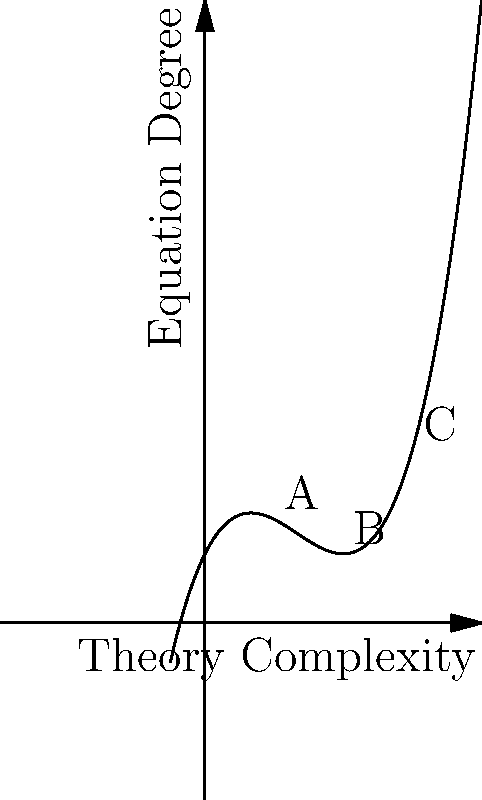In the context of scientific theory complexity and polynomial equation degree, the graph above represents a hypothetical relationship between these two variables. Points A, B, and C correspond to three distinct scientific theories. If we consider the rate of change in equation degree with respect to theory complexity, which theory demonstrates the most rapid increase in equation degree as complexity grows? To determine which theory demonstrates the most rapid increase in equation degree as complexity grows, we need to analyze the rate of change (slope) at each point:

1. The graph represents a cubic function, suggesting a varying rate of change.

2. The rate of change at any point is given by the derivative of the function at that point.

3. For a cubic function $f(x) = ax^3 + bx^2 + cx + d$, the derivative is $f'(x) = 3ax^2 + 2bx + c$.

4. The steepness of the curve at each point indicates the rate of change:
   - Point A has a relatively gentle slope
   - Point B has a steeper slope than A
   - Point C has the steepest slope among the three

5. The increasing steepness from A to C indicates that the rate of change is increasing as we move right on the x-axis (increasing complexity).

6. Therefore, the theory corresponding to point C demonstrates the most rapid increase in equation degree as complexity grows.
Answer: Theory C 